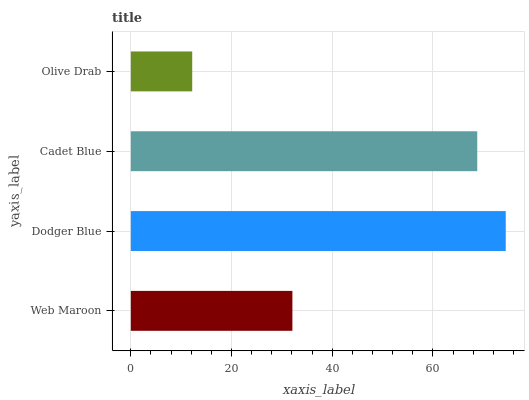Is Olive Drab the minimum?
Answer yes or no. Yes. Is Dodger Blue the maximum?
Answer yes or no. Yes. Is Cadet Blue the minimum?
Answer yes or no. No. Is Cadet Blue the maximum?
Answer yes or no. No. Is Dodger Blue greater than Cadet Blue?
Answer yes or no. Yes. Is Cadet Blue less than Dodger Blue?
Answer yes or no. Yes. Is Cadet Blue greater than Dodger Blue?
Answer yes or no. No. Is Dodger Blue less than Cadet Blue?
Answer yes or no. No. Is Cadet Blue the high median?
Answer yes or no. Yes. Is Web Maroon the low median?
Answer yes or no. Yes. Is Web Maroon the high median?
Answer yes or no. No. Is Dodger Blue the low median?
Answer yes or no. No. 